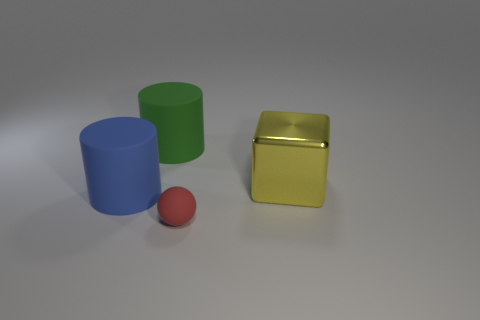Subtract all green cylinders. How many cylinders are left? 1 Add 4 big cylinders. How many objects exist? 8 Subtract all yellow spheres. Subtract all red cubes. How many spheres are left? 1 Add 3 big gray metal spheres. How many big gray metal spheres exist? 3 Subtract 0 green blocks. How many objects are left? 4 Subtract all blocks. How many objects are left? 3 Subtract 1 cylinders. How many cylinders are left? 1 Subtract all red spheres. How many purple cylinders are left? 0 Subtract all big green cylinders. Subtract all big red balls. How many objects are left? 3 Add 2 green matte things. How many green matte things are left? 3 